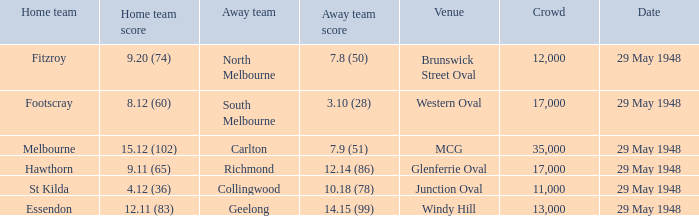During melbourne's home game, who was the away team? Carlton. Write the full table. {'header': ['Home team', 'Home team score', 'Away team', 'Away team score', 'Venue', 'Crowd', 'Date'], 'rows': [['Fitzroy', '9.20 (74)', 'North Melbourne', '7.8 (50)', 'Brunswick Street Oval', '12,000', '29 May 1948'], ['Footscray', '8.12 (60)', 'South Melbourne', '3.10 (28)', 'Western Oval', '17,000', '29 May 1948'], ['Melbourne', '15.12 (102)', 'Carlton', '7.9 (51)', 'MCG', '35,000', '29 May 1948'], ['Hawthorn', '9.11 (65)', 'Richmond', '12.14 (86)', 'Glenferrie Oval', '17,000', '29 May 1948'], ['St Kilda', '4.12 (36)', 'Collingwood', '10.18 (78)', 'Junction Oval', '11,000', '29 May 1948'], ['Essendon', '12.11 (83)', 'Geelong', '14.15 (99)', 'Windy Hill', '13,000', '29 May 1948']]} 